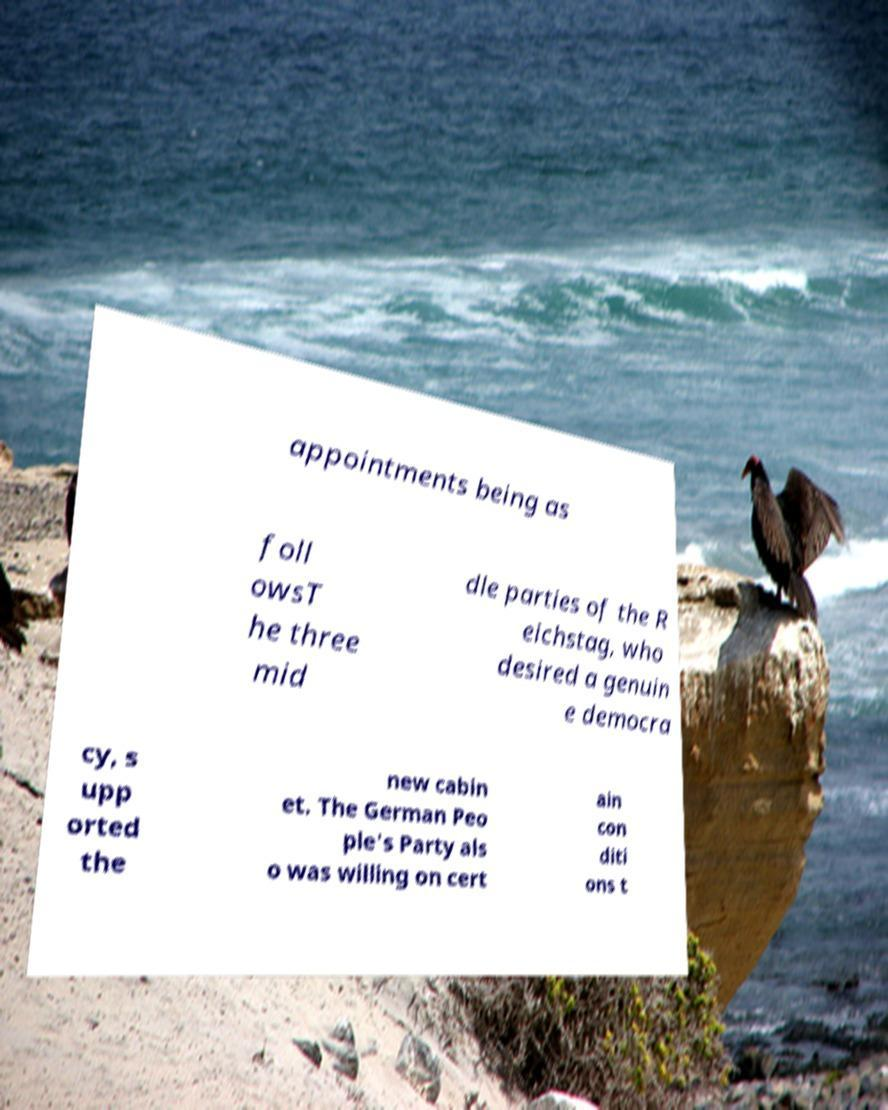Could you extract and type out the text from this image? appointments being as foll owsT he three mid dle parties of the R eichstag, who desired a genuin e democra cy, s upp orted the new cabin et. The German Peo ple's Party als o was willing on cert ain con diti ons t 